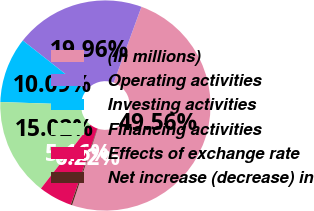Convert chart. <chart><loc_0><loc_0><loc_500><loc_500><pie_chart><fcel>(In millions)<fcel>Operating activities<fcel>Investing activities<fcel>Financing activities<fcel>Effects of exchange rate<fcel>Net increase (decrease) in<nl><fcel>49.56%<fcel>19.96%<fcel>10.09%<fcel>15.02%<fcel>5.16%<fcel>0.22%<nl></chart> 